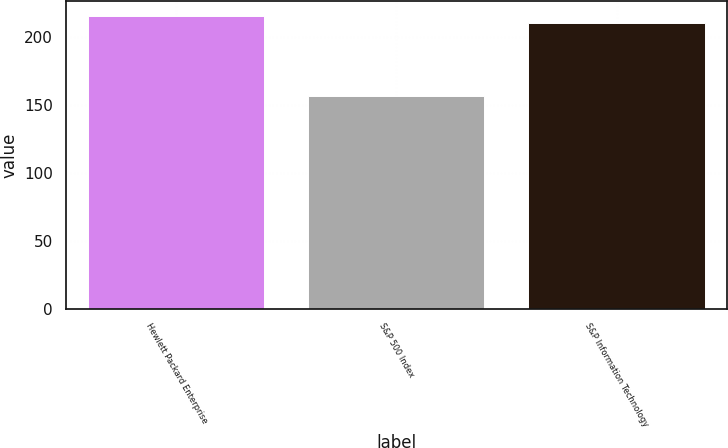Convert chart to OTSL. <chart><loc_0><loc_0><loc_500><loc_500><bar_chart><fcel>Hewlett Packard Enterprise<fcel>S&P 500 Index<fcel>S&P Information Technology<nl><fcel>215.38<fcel>156.66<fcel>209.93<nl></chart> 